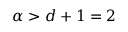<formula> <loc_0><loc_0><loc_500><loc_500>\alpha > d + 1 = 2</formula> 